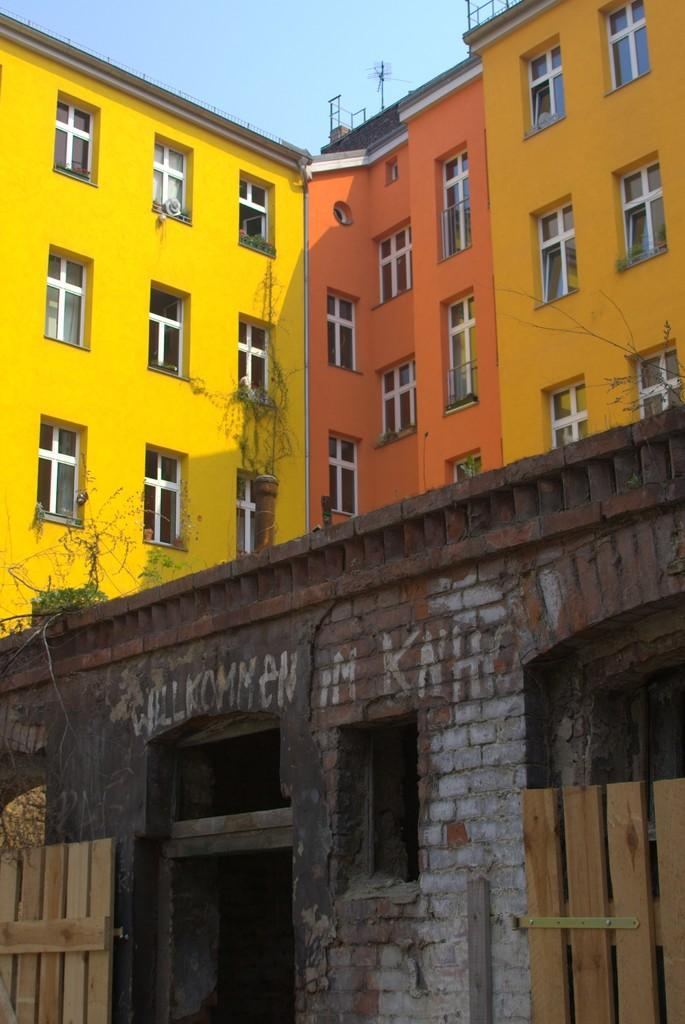What type of structures are present in the image? There are buildings in the image. Can you describe one of the buildings in the image? One of the buildings is yellow. What is visible at the top of the image? The sky is visible at the top of the image. What type of soup is being served in the image? There is no soup present in the image. What rule is being enforced in the image? There is no rule being enforced in the image. Where is the office located in the image? There is no office present in the image. 